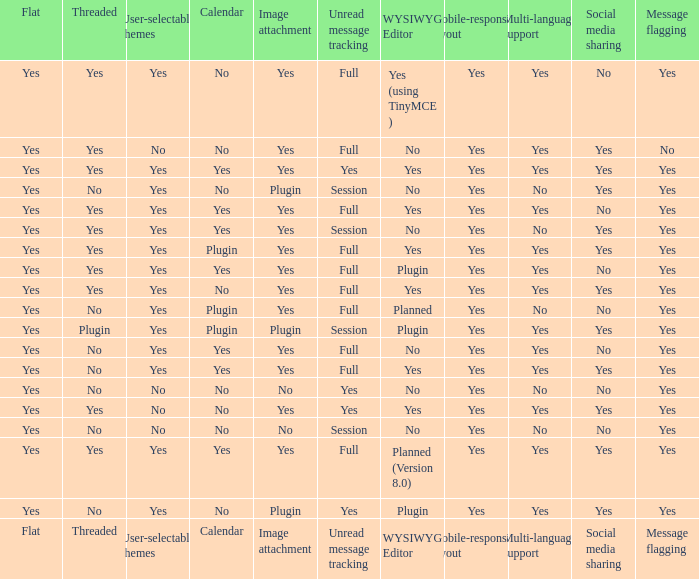Which WYSIWYG Editor has a User-selectable themes of yes, and an Unread message tracking of session, and an Image attachment of plugin? No, Plugin. Can you give me this table as a dict? {'header': ['Flat', 'Threaded', 'User-selectable themes', 'Calendar', 'Image attachment', 'Unread message tracking', 'WYSIWYG Editor', 'Mobile-responsive layout', 'Multi-language support', 'Social media sharing', 'Message flagging'], 'rows': [['Yes', 'Yes', 'Yes', 'No', 'Yes', 'Full', 'Yes (using TinyMCE )', 'Yes', 'Yes', 'No', 'Yes'], ['Yes', 'Yes', 'No', 'No', 'Yes', 'Full', 'No', 'Yes', 'Yes', 'Yes', 'No'], ['Yes', 'Yes', 'Yes', 'Yes', 'Yes', 'Yes', 'Yes', 'Yes', 'Yes', 'Yes', 'Yes'], ['Yes', 'No', 'Yes', 'No', 'Plugin', 'Session', 'No', 'Yes', 'No', 'Yes', 'Yes'], ['Yes', 'Yes', 'Yes', 'Yes', 'Yes', 'Full', 'Yes', 'Yes', 'Yes', 'No', 'Yes'], ['Yes', 'Yes', 'Yes', 'Yes', 'Yes', 'Session', 'No', 'Yes', 'No', 'Yes', 'Yes'], ['Yes', 'Yes', 'Yes', 'Plugin', 'Yes', 'Full', 'Yes', 'Yes', 'Yes', 'Yes', 'Yes'], ['Yes', 'Yes', 'Yes', 'Yes', 'Yes', 'Full', 'Plugin', 'Yes', 'Yes', 'No', 'Yes'], ['Yes', 'Yes', 'Yes', 'No', 'Yes', 'Full', 'Yes', 'Yes', 'Yes', 'Yes', 'Yes'], ['Yes', 'No', 'Yes', 'Plugin', 'Yes', 'Full', 'Planned', 'Yes', 'No', 'No', 'Yes'], ['Yes', 'Plugin', 'Yes', 'Plugin', 'Plugin', 'Session', 'Plugin', 'Yes', 'Yes', 'Yes', 'Yes'], ['Yes', 'No', 'Yes', 'Yes', 'Yes', 'Full', 'No', 'Yes', 'Yes', 'No', 'Yes'], ['Yes', 'No', 'Yes', 'Yes', 'Yes', 'Full', 'Yes', 'Yes', 'Yes', 'Yes', 'Yes'], ['Yes', 'No', 'No', 'No', 'No', 'Yes', 'No', 'Yes', 'No', 'No', 'Yes'], ['Yes', 'Yes', 'No', 'No', 'Yes', 'Yes', 'Yes', 'Yes', 'Yes', 'Yes', 'Yes'], ['Yes', 'No', 'No', 'No', 'No', 'Session', 'No', 'Yes', 'No', 'No', 'Yes'], ['Yes', 'Yes', 'Yes', 'Yes', 'Yes', 'Full', 'Planned (Version 8.0)', 'Yes', 'Yes', 'Yes', 'Yes'], ['Yes', 'No', 'Yes', 'No', 'Plugin', 'Yes', 'Plugin', 'Yes', 'Yes', 'Yes', 'Yes'], ['Flat', 'Threaded', 'User-selectable themes', 'Calendar', 'Image attachment', 'Unread message tracking', 'WYSIWYG Editor', 'Mobile-responsive layout', 'Multi-language support', 'Social media sharing', 'Message flagging']]} 